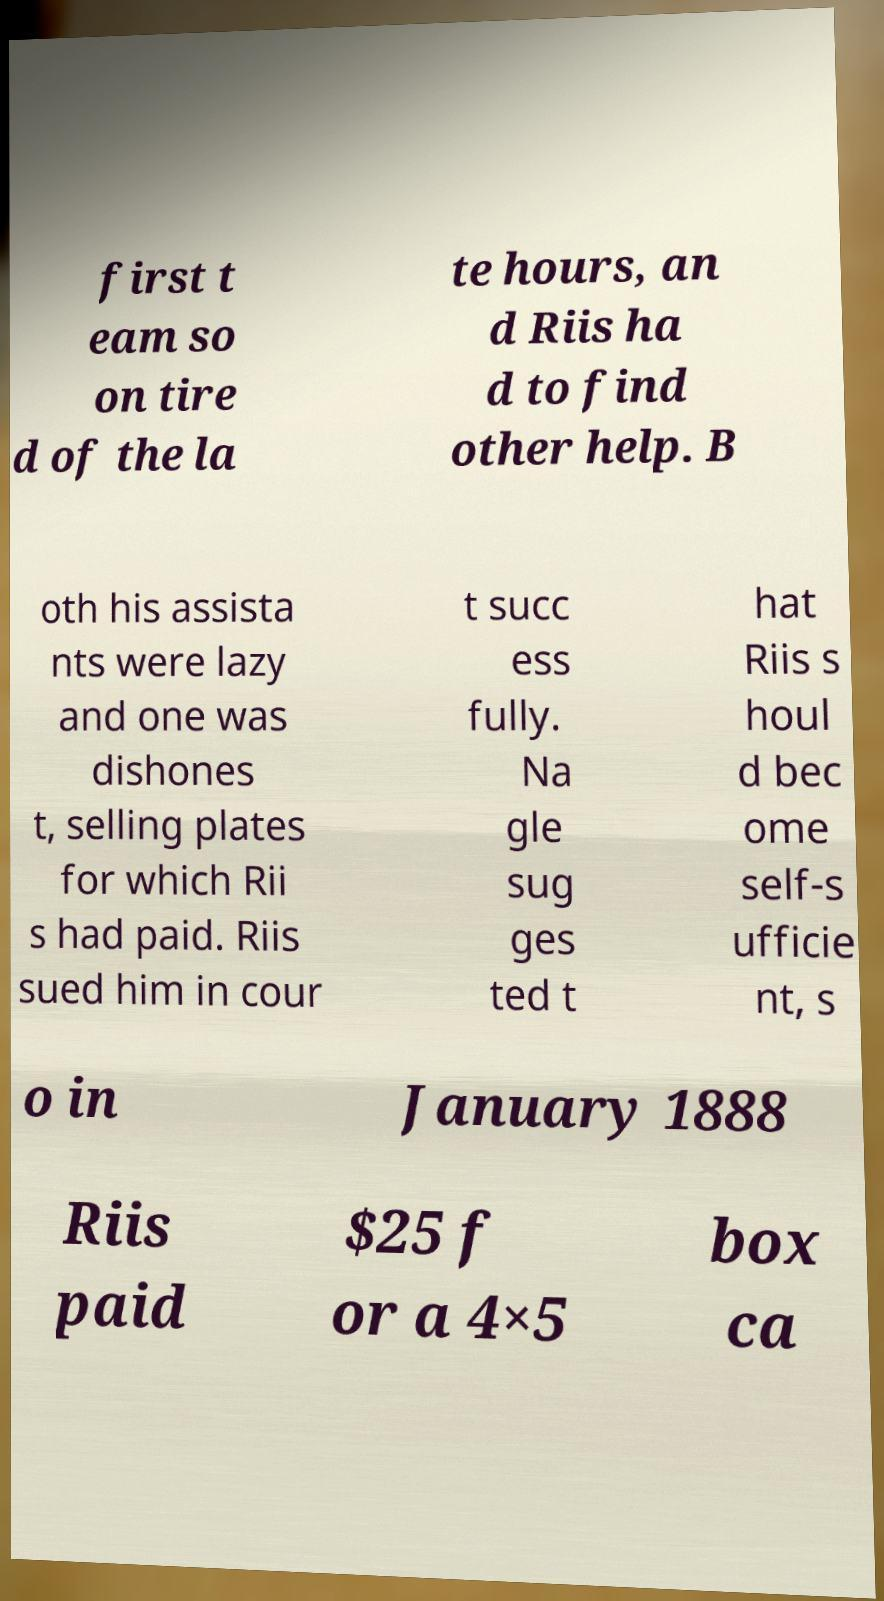Could you extract and type out the text from this image? first t eam so on tire d of the la te hours, an d Riis ha d to find other help. B oth his assista nts were lazy and one was dishones t, selling plates for which Rii s had paid. Riis sued him in cour t succ ess fully. Na gle sug ges ted t hat Riis s houl d bec ome self-s ufficie nt, s o in January 1888 Riis paid $25 f or a 4×5 box ca 